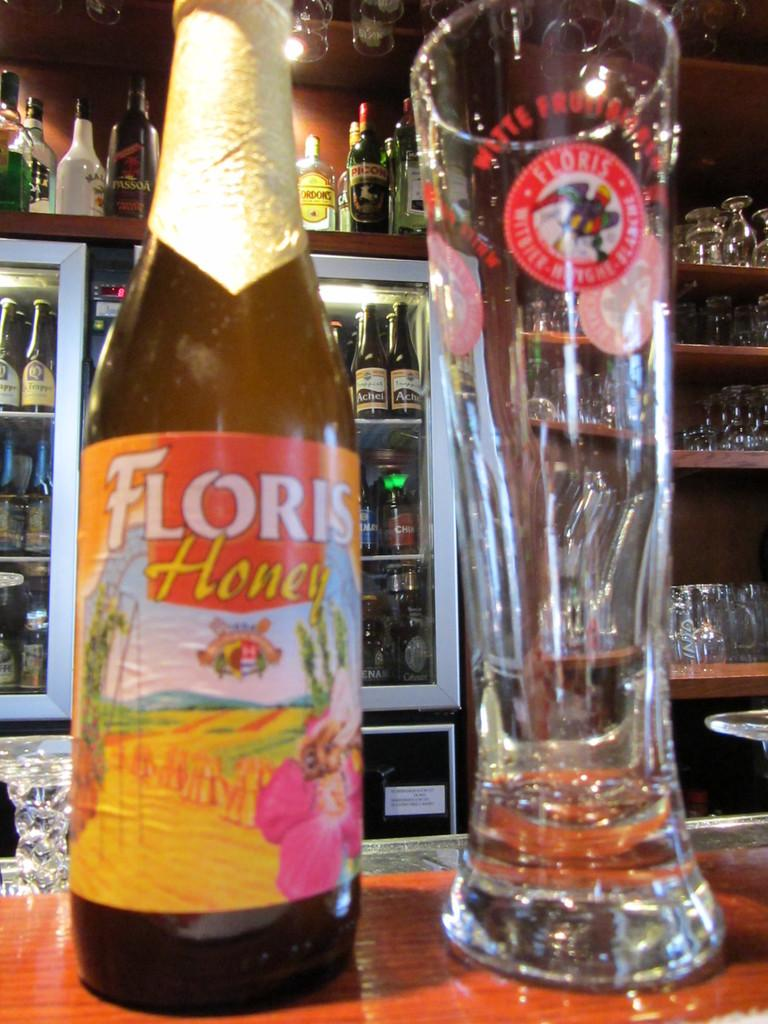<image>
Relay a brief, clear account of the picture shown. Bottle of Floris HOney next to a tall and empty glass cup. 